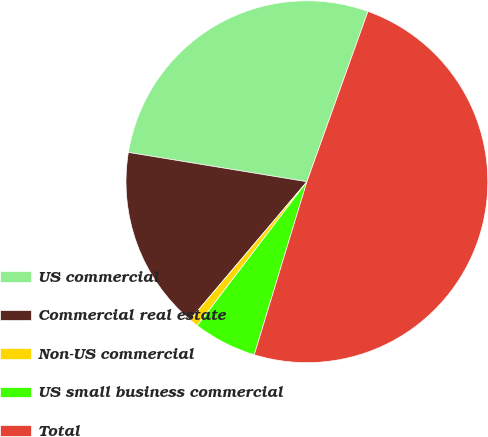Convert chart to OTSL. <chart><loc_0><loc_0><loc_500><loc_500><pie_chart><fcel>US commercial<fcel>Commercial real estate<fcel>Non-US commercial<fcel>US small business commercial<fcel>Total<nl><fcel>27.89%<fcel>16.41%<fcel>0.82%<fcel>5.66%<fcel>49.22%<nl></chart> 